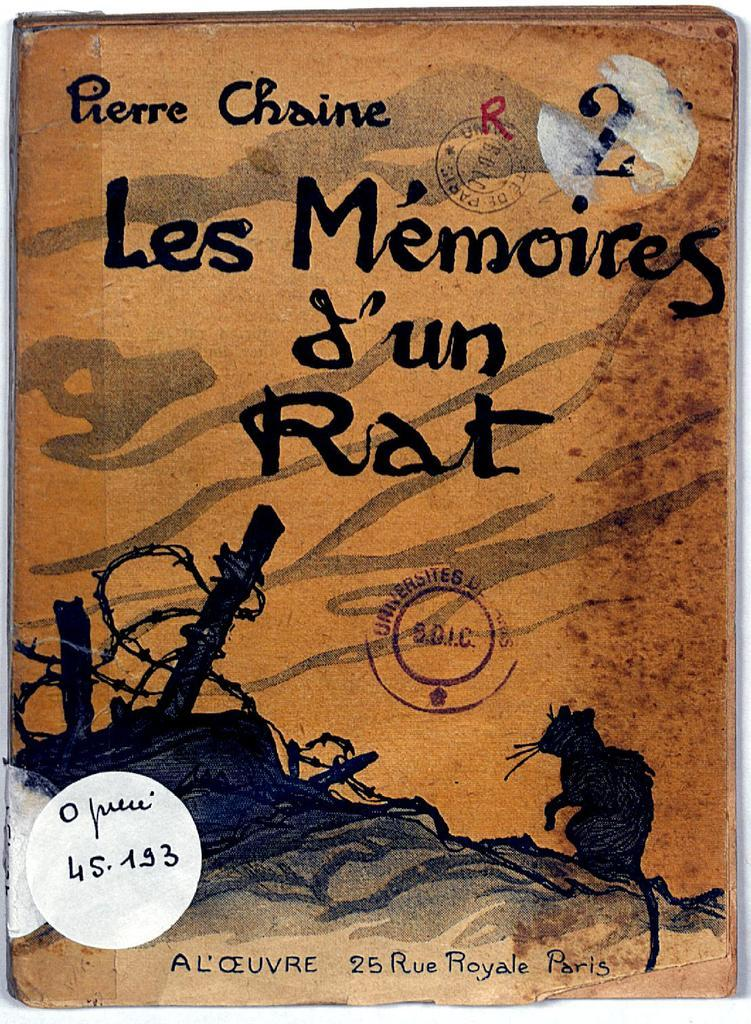<image>
Offer a succinct explanation of the picture presented. The french book Les Memoires d'un Rat, by Pierre Chaine. 